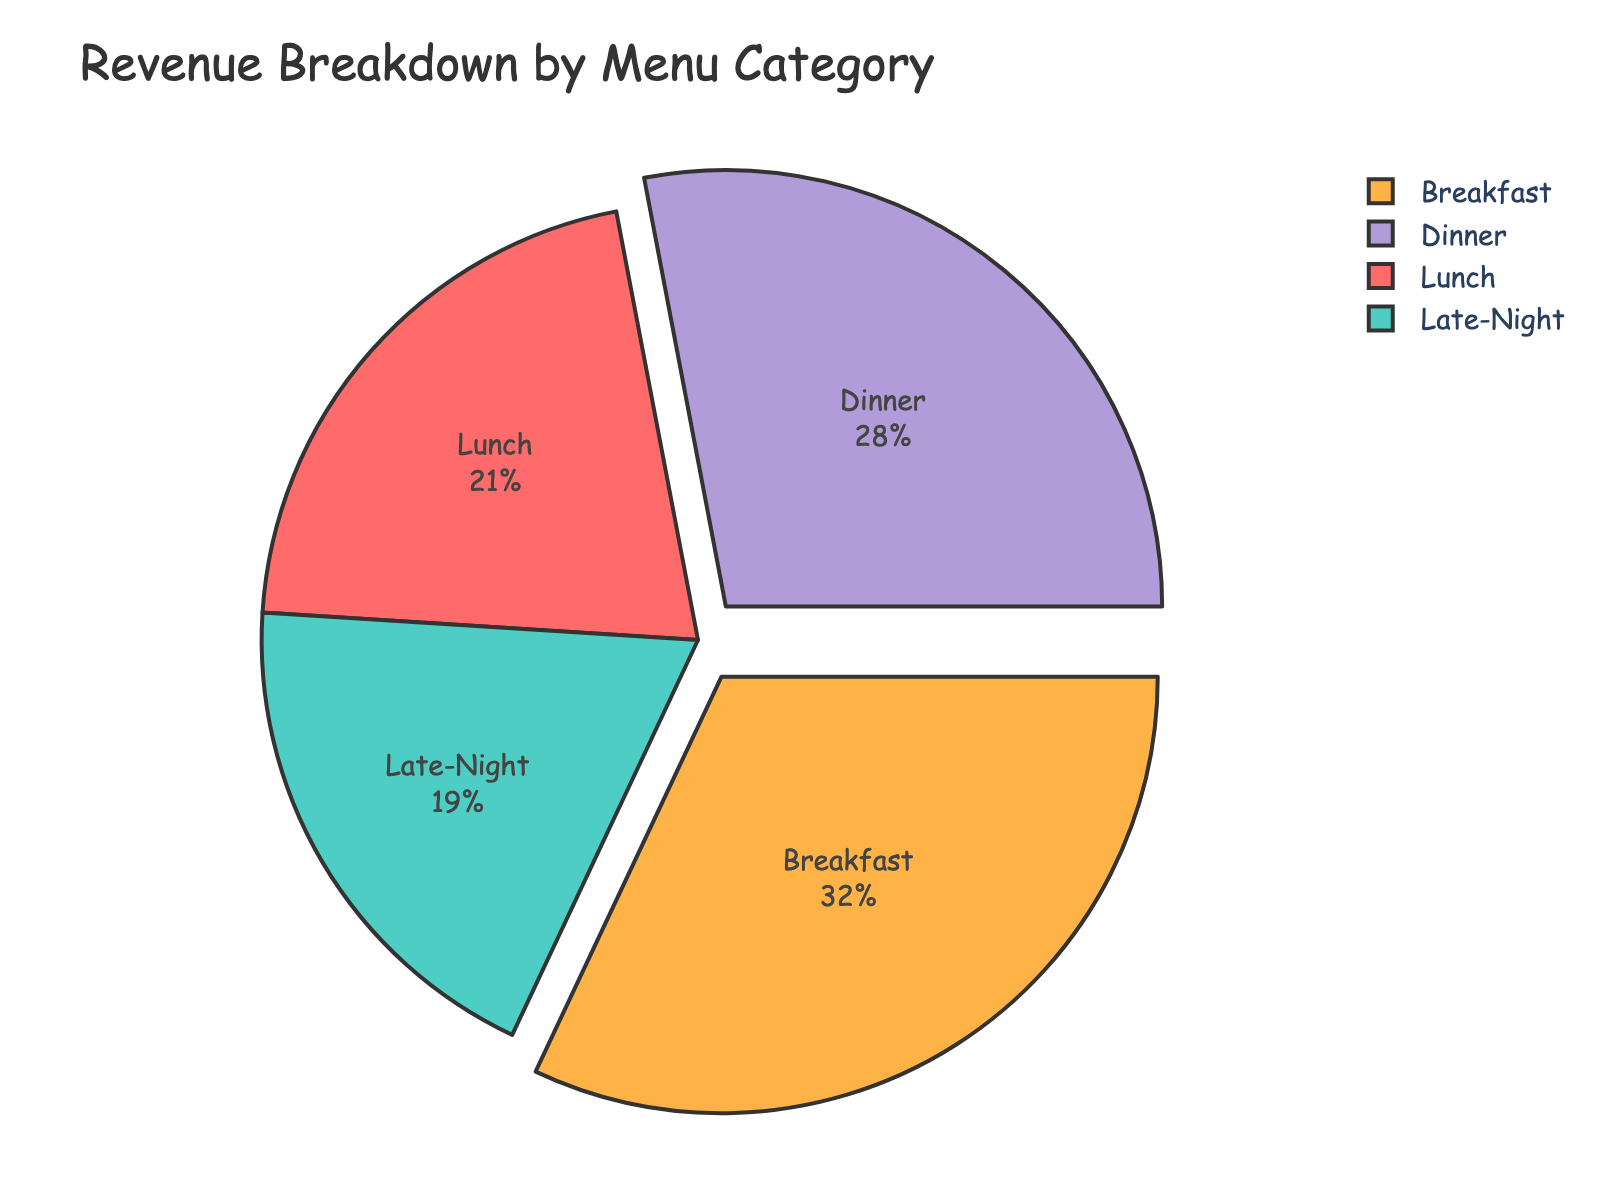Which menu category contributes the most to the revenue? The largest slice in the pie chart represents the category with the highest revenue percentage. Breakfast has the largest slice.
Answer: Breakfast Which menu category has the smallest revenue share? The smallest slice in the pie chart corresponds to the category with the lowest revenue percentage. Late-Night has the smallest slice.
Answer: Late-Night By how much percent does Breakfast revenue exceed Lunch revenue? Breakfast is 32% and Lunch is 21%. The difference is 32% - 21%.
Answer: 11% If Breakfast and Dinner revenues are combined, what is their total percentage? Breakfast contributes 32% and Dinner 28%. Summing them gives us 32% + 28%.
Answer: 60% Which two categories have an equal visual pull-out effect? Visual cues can indicate a pull-out effect, and in this pie chart, Breakfast and Dinner show a slight separation from the pie, indicating they have been pulled out equally.
Answer: Breakfast and Dinner How much less is Late-Night revenue compared to Dinner revenue? Dinner revenue is 28%, and Late-Night is 19%. The difference is 28% - 19%.
Answer: 9% What is the average revenue percentage of Lunch and Late-Night categories? Lunch revenue is 21% and Late-Night is 19%. Calculating the average: (21% + 19%) / 2.
Answer: 20% Is the revenue from Dinner greater than the combined revenue of Lunch and Late-Night? Dinner revenue is 28%. The combined revenue of Lunch (21%) and Late-Night (19%) is 21% + 19% = 40%. Since 28% < 40%, Dinner revenue is not greater.
Answer: No Which portion of the pie chart is greenish-blue? Visual inspection shows that the greenish-blue segment corresponds to Late-Night category.
Answer: Late-Night What is the difference in revenue percentage between the category with the highest revenue and the category with the lowest revenue? The highest revenue is from Breakfast (32%), and the lowest is from Late-Night (19%). The difference is 32% - 19%.
Answer: 13% 